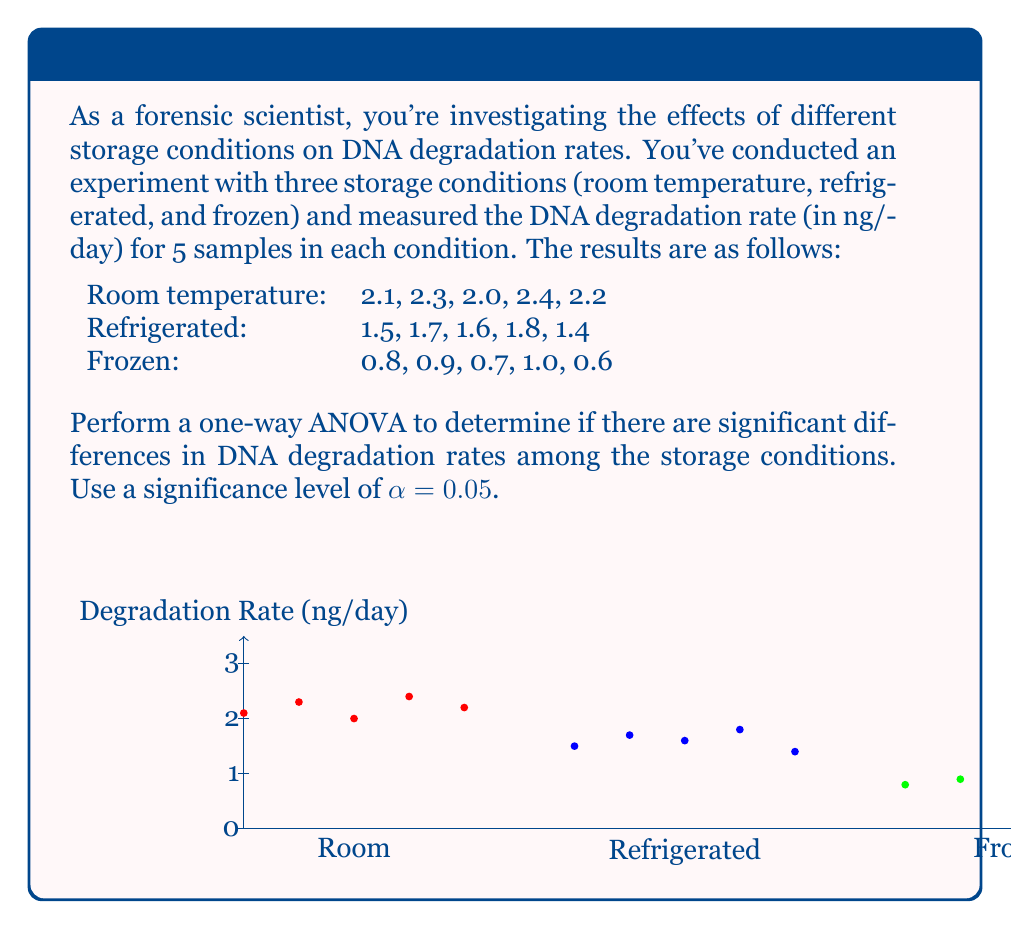Could you help me with this problem? To perform a one-way ANOVA, we'll follow these steps:

1. Calculate the sum of squares between groups (SSB) and within groups (SSW)
2. Calculate the degrees of freedom for between groups (dfB) and within groups (dfW)
3. Calculate the mean squares between groups (MSB) and within groups (MSW)
4. Calculate the F-statistic
5. Compare the F-statistic to the critical F-value

Step 1: Calculate SSB and SSW

First, we need to calculate the grand mean and group means:

Grand mean: $\bar{X} = \frac{2.1 + 2.3 + ... + 0.6}{15} = 1.60$

Room temperature mean: $\bar{X}_1 = 2.20$
Refrigerated mean: $\bar{X}_2 = 1.60$
Frozen mean: $\bar{X}_3 = 0.80$

SSB = $\sum_{i=1}^k n_i(\bar{X}_i - \bar{X})^2$
    = $5(2.20 - 1.60)^2 + 5(1.60 - 1.60)^2 + 5(0.80 - 1.60)^2$
    = $5(0.60)^2 + 5(0)^2 + 5(-0.80)^2$
    = $1.80 + 0 + 3.20 = 5.00$

SSW = $\sum_{i=1}^k \sum_{j=1}^{n_i} (X_{ij} - \bar{X}_i)^2$
    = $[(2.1 - 2.20)^2 + ... + (2.2 - 2.20)^2]$
    + $[(1.5 - 1.60)^2 + ... + (1.4 - 1.60)^2]$
    + $[(0.8 - 0.80)^2 + ... + (0.6 - 0.80)^2]$
    = $0.10 + 0.10 + 0.10 = 0.30$

Step 2: Calculate degrees of freedom

dfB = k - 1 = 3 - 1 = 2
dfW = N - k = 15 - 3 = 12

Step 3: Calculate mean squares

MSB = SSB / dfB = 5.00 / 2 = 2.50
MSW = SSW / dfW = 0.30 / 12 = 0.025

Step 4: Calculate F-statistic

F = MSB / MSW = 2.50 / 0.025 = 100

Step 5: Compare to critical F-value

For α = 0.05, dfB = 2, and dfW = 12, the critical F-value is approximately 3.89.

Since our calculated F-statistic (100) is greater than the critical F-value (3.89), we reject the null hypothesis.
Answer: F(2,12) = 100, p < 0.05. Significant differences exist in DNA degradation rates among storage conditions. 